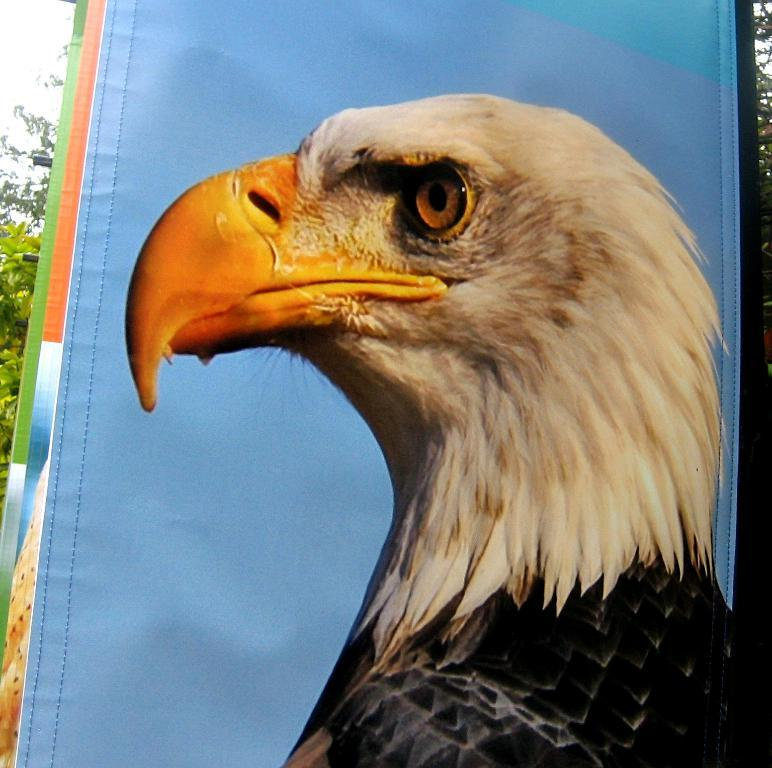What is the main object in the image? There is a banner in the image. What is depicted on the banner? There is an eagle depicted on the banner. What can be seen in the background of the image? There are trees visible behind the banner. Can you tell me how many marks the donkey made on the banner? There is no donkey present in the image, and therefore no marks can be attributed to it. 